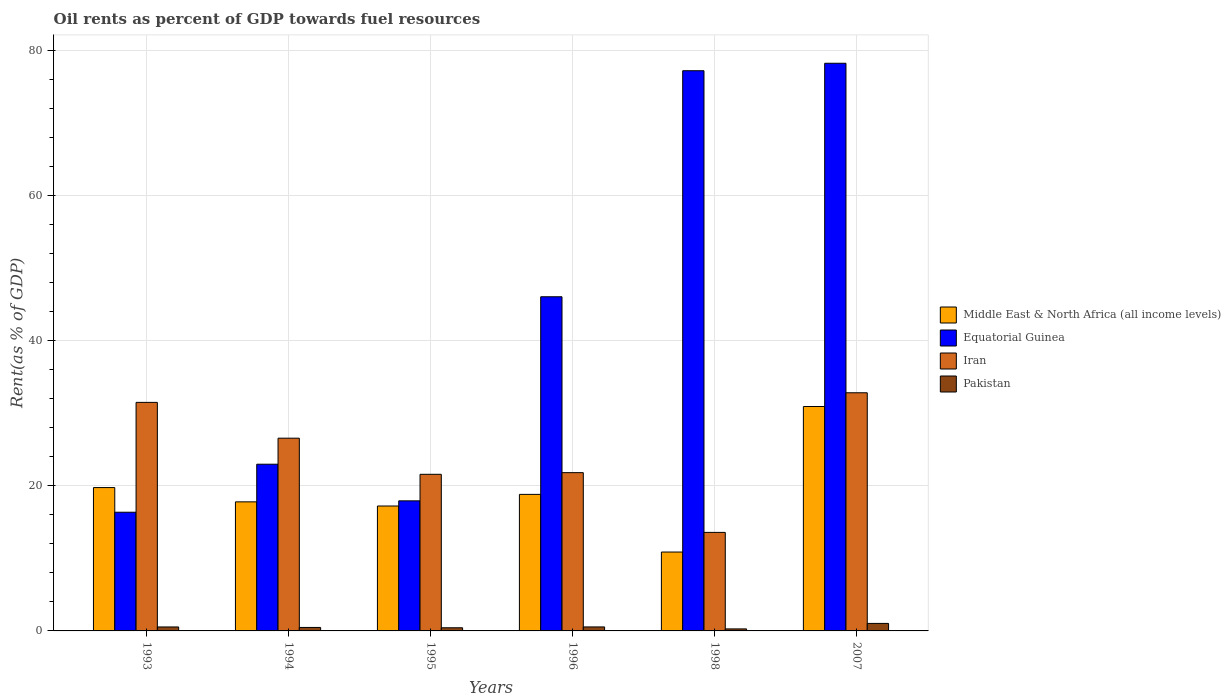How many bars are there on the 5th tick from the right?
Make the answer very short. 4. What is the label of the 3rd group of bars from the left?
Keep it short and to the point. 1995. In how many cases, is the number of bars for a given year not equal to the number of legend labels?
Keep it short and to the point. 0. What is the oil rent in Middle East & North Africa (all income levels) in 2007?
Give a very brief answer. 30.94. Across all years, what is the maximum oil rent in Iran?
Your response must be concise. 32.83. Across all years, what is the minimum oil rent in Pakistan?
Offer a terse response. 0.28. What is the total oil rent in Middle East & North Africa (all income levels) in the graph?
Provide a succinct answer. 115.41. What is the difference between the oil rent in Equatorial Guinea in 1996 and that in 1998?
Give a very brief answer. -31.16. What is the difference between the oil rent in Iran in 1994 and the oil rent in Pakistan in 1995?
Provide a succinct answer. 26.14. What is the average oil rent in Pakistan per year?
Your answer should be very brief. 0.55. In the year 1994, what is the difference between the oil rent in Middle East & North Africa (all income levels) and oil rent in Equatorial Guinea?
Make the answer very short. -5.19. What is the ratio of the oil rent in Equatorial Guinea in 1995 to that in 1996?
Offer a terse response. 0.39. Is the oil rent in Equatorial Guinea in 1996 less than that in 2007?
Ensure brevity in your answer.  Yes. What is the difference between the highest and the second highest oil rent in Iran?
Make the answer very short. 1.32. What is the difference between the highest and the lowest oil rent in Equatorial Guinea?
Keep it short and to the point. 61.89. In how many years, is the oil rent in Pakistan greater than the average oil rent in Pakistan taken over all years?
Your answer should be compact. 1. Is the sum of the oil rent in Equatorial Guinea in 1995 and 2007 greater than the maximum oil rent in Pakistan across all years?
Offer a terse response. Yes. Is it the case that in every year, the sum of the oil rent in Iran and oil rent in Middle East & North Africa (all income levels) is greater than the sum of oil rent in Pakistan and oil rent in Equatorial Guinea?
Your answer should be compact. No. What does the 3rd bar from the left in 1998 represents?
Provide a short and direct response. Iran. What does the 3rd bar from the right in 1995 represents?
Provide a short and direct response. Equatorial Guinea. Is it the case that in every year, the sum of the oil rent in Iran and oil rent in Pakistan is greater than the oil rent in Equatorial Guinea?
Make the answer very short. No. How many bars are there?
Give a very brief answer. 24. Are all the bars in the graph horizontal?
Your response must be concise. No. How many years are there in the graph?
Offer a terse response. 6. What is the difference between two consecutive major ticks on the Y-axis?
Your answer should be very brief. 20. Does the graph contain grids?
Your answer should be compact. Yes. How many legend labels are there?
Make the answer very short. 4. What is the title of the graph?
Your response must be concise. Oil rents as percent of GDP towards fuel resources. Does "Upper middle income" appear as one of the legend labels in the graph?
Offer a terse response. No. What is the label or title of the X-axis?
Your answer should be very brief. Years. What is the label or title of the Y-axis?
Give a very brief answer. Rent(as % of GDP). What is the Rent(as % of GDP) in Middle East & North Africa (all income levels) in 1993?
Your response must be concise. 19.76. What is the Rent(as % of GDP) of Equatorial Guinea in 1993?
Your response must be concise. 16.36. What is the Rent(as % of GDP) in Iran in 1993?
Offer a very short reply. 31.51. What is the Rent(as % of GDP) in Pakistan in 1993?
Provide a succinct answer. 0.55. What is the Rent(as % of GDP) of Middle East & North Africa (all income levels) in 1994?
Your answer should be very brief. 17.79. What is the Rent(as % of GDP) in Equatorial Guinea in 1994?
Your answer should be compact. 22.98. What is the Rent(as % of GDP) of Iran in 1994?
Provide a succinct answer. 26.57. What is the Rent(as % of GDP) of Pakistan in 1994?
Your answer should be very brief. 0.48. What is the Rent(as % of GDP) of Middle East & North Africa (all income levels) in 1995?
Give a very brief answer. 17.22. What is the Rent(as % of GDP) of Equatorial Guinea in 1995?
Provide a short and direct response. 17.93. What is the Rent(as % of GDP) of Iran in 1995?
Keep it short and to the point. 21.59. What is the Rent(as % of GDP) of Pakistan in 1995?
Offer a terse response. 0.43. What is the Rent(as % of GDP) of Middle East & North Africa (all income levels) in 1996?
Your answer should be very brief. 18.82. What is the Rent(as % of GDP) in Equatorial Guinea in 1996?
Your answer should be compact. 46.07. What is the Rent(as % of GDP) in Iran in 1996?
Your answer should be compact. 21.82. What is the Rent(as % of GDP) in Pakistan in 1996?
Keep it short and to the point. 0.55. What is the Rent(as % of GDP) in Middle East & North Africa (all income levels) in 1998?
Make the answer very short. 10.87. What is the Rent(as % of GDP) of Equatorial Guinea in 1998?
Keep it short and to the point. 77.23. What is the Rent(as % of GDP) of Iran in 1998?
Make the answer very short. 13.58. What is the Rent(as % of GDP) in Pakistan in 1998?
Give a very brief answer. 0.28. What is the Rent(as % of GDP) in Middle East & North Africa (all income levels) in 2007?
Your answer should be compact. 30.94. What is the Rent(as % of GDP) of Equatorial Guinea in 2007?
Keep it short and to the point. 78.25. What is the Rent(as % of GDP) of Iran in 2007?
Your answer should be very brief. 32.83. What is the Rent(as % of GDP) of Pakistan in 2007?
Make the answer very short. 1.03. Across all years, what is the maximum Rent(as % of GDP) in Middle East & North Africa (all income levels)?
Provide a succinct answer. 30.94. Across all years, what is the maximum Rent(as % of GDP) in Equatorial Guinea?
Offer a terse response. 78.25. Across all years, what is the maximum Rent(as % of GDP) in Iran?
Your answer should be compact. 32.83. Across all years, what is the maximum Rent(as % of GDP) in Pakistan?
Ensure brevity in your answer.  1.03. Across all years, what is the minimum Rent(as % of GDP) of Middle East & North Africa (all income levels)?
Offer a very short reply. 10.87. Across all years, what is the minimum Rent(as % of GDP) in Equatorial Guinea?
Offer a terse response. 16.36. Across all years, what is the minimum Rent(as % of GDP) in Iran?
Provide a succinct answer. 13.58. Across all years, what is the minimum Rent(as % of GDP) in Pakistan?
Ensure brevity in your answer.  0.28. What is the total Rent(as % of GDP) in Middle East & North Africa (all income levels) in the graph?
Your answer should be very brief. 115.41. What is the total Rent(as % of GDP) in Equatorial Guinea in the graph?
Your response must be concise. 258.82. What is the total Rent(as % of GDP) in Iran in the graph?
Your response must be concise. 147.89. What is the total Rent(as % of GDP) in Pakistan in the graph?
Ensure brevity in your answer.  3.32. What is the difference between the Rent(as % of GDP) in Middle East & North Africa (all income levels) in 1993 and that in 1994?
Offer a terse response. 1.97. What is the difference between the Rent(as % of GDP) of Equatorial Guinea in 1993 and that in 1994?
Offer a very short reply. -6.62. What is the difference between the Rent(as % of GDP) of Iran in 1993 and that in 1994?
Your response must be concise. 4.94. What is the difference between the Rent(as % of GDP) of Pakistan in 1993 and that in 1994?
Provide a short and direct response. 0.07. What is the difference between the Rent(as % of GDP) in Middle East & North Africa (all income levels) in 1993 and that in 1995?
Your answer should be very brief. 2.54. What is the difference between the Rent(as % of GDP) of Equatorial Guinea in 1993 and that in 1995?
Offer a terse response. -1.57. What is the difference between the Rent(as % of GDP) in Iran in 1993 and that in 1995?
Give a very brief answer. 9.92. What is the difference between the Rent(as % of GDP) in Pakistan in 1993 and that in 1995?
Ensure brevity in your answer.  0.11. What is the difference between the Rent(as % of GDP) of Middle East & North Africa (all income levels) in 1993 and that in 1996?
Your answer should be compact. 0.94. What is the difference between the Rent(as % of GDP) in Equatorial Guinea in 1993 and that in 1996?
Offer a terse response. -29.7. What is the difference between the Rent(as % of GDP) in Iran in 1993 and that in 1996?
Offer a terse response. 9.69. What is the difference between the Rent(as % of GDP) of Pakistan in 1993 and that in 1996?
Your answer should be very brief. -0. What is the difference between the Rent(as % of GDP) of Middle East & North Africa (all income levels) in 1993 and that in 1998?
Offer a terse response. 8.89. What is the difference between the Rent(as % of GDP) of Equatorial Guinea in 1993 and that in 1998?
Give a very brief answer. -60.86. What is the difference between the Rent(as % of GDP) of Iran in 1993 and that in 1998?
Offer a very short reply. 17.92. What is the difference between the Rent(as % of GDP) in Pakistan in 1993 and that in 1998?
Ensure brevity in your answer.  0.27. What is the difference between the Rent(as % of GDP) of Middle East & North Africa (all income levels) in 1993 and that in 2007?
Provide a short and direct response. -11.17. What is the difference between the Rent(as % of GDP) of Equatorial Guinea in 1993 and that in 2007?
Provide a succinct answer. -61.89. What is the difference between the Rent(as % of GDP) in Iran in 1993 and that in 2007?
Your response must be concise. -1.32. What is the difference between the Rent(as % of GDP) of Pakistan in 1993 and that in 2007?
Your answer should be compact. -0.49. What is the difference between the Rent(as % of GDP) in Middle East & North Africa (all income levels) in 1994 and that in 1995?
Offer a very short reply. 0.57. What is the difference between the Rent(as % of GDP) in Equatorial Guinea in 1994 and that in 1995?
Offer a very short reply. 5.05. What is the difference between the Rent(as % of GDP) of Iran in 1994 and that in 1995?
Your answer should be compact. 4.98. What is the difference between the Rent(as % of GDP) in Pakistan in 1994 and that in 1995?
Provide a succinct answer. 0.04. What is the difference between the Rent(as % of GDP) in Middle East & North Africa (all income levels) in 1994 and that in 1996?
Provide a short and direct response. -1.03. What is the difference between the Rent(as % of GDP) of Equatorial Guinea in 1994 and that in 1996?
Ensure brevity in your answer.  -23.08. What is the difference between the Rent(as % of GDP) in Iran in 1994 and that in 1996?
Offer a very short reply. 4.75. What is the difference between the Rent(as % of GDP) of Pakistan in 1994 and that in 1996?
Provide a succinct answer. -0.07. What is the difference between the Rent(as % of GDP) of Middle East & North Africa (all income levels) in 1994 and that in 1998?
Offer a terse response. 6.92. What is the difference between the Rent(as % of GDP) of Equatorial Guinea in 1994 and that in 1998?
Offer a terse response. -54.25. What is the difference between the Rent(as % of GDP) in Iran in 1994 and that in 1998?
Offer a terse response. 12.99. What is the difference between the Rent(as % of GDP) of Pakistan in 1994 and that in 1998?
Keep it short and to the point. 0.2. What is the difference between the Rent(as % of GDP) in Middle East & North Africa (all income levels) in 1994 and that in 2007?
Provide a succinct answer. -13.14. What is the difference between the Rent(as % of GDP) in Equatorial Guinea in 1994 and that in 2007?
Provide a succinct answer. -55.27. What is the difference between the Rent(as % of GDP) in Iran in 1994 and that in 2007?
Your response must be concise. -6.26. What is the difference between the Rent(as % of GDP) in Pakistan in 1994 and that in 2007?
Ensure brevity in your answer.  -0.56. What is the difference between the Rent(as % of GDP) in Middle East & North Africa (all income levels) in 1995 and that in 1996?
Provide a succinct answer. -1.6. What is the difference between the Rent(as % of GDP) of Equatorial Guinea in 1995 and that in 1996?
Keep it short and to the point. -28.14. What is the difference between the Rent(as % of GDP) of Iran in 1995 and that in 1996?
Provide a succinct answer. -0.23. What is the difference between the Rent(as % of GDP) of Pakistan in 1995 and that in 1996?
Ensure brevity in your answer.  -0.12. What is the difference between the Rent(as % of GDP) of Middle East & North Africa (all income levels) in 1995 and that in 1998?
Offer a very short reply. 6.35. What is the difference between the Rent(as % of GDP) in Equatorial Guinea in 1995 and that in 1998?
Your answer should be compact. -59.3. What is the difference between the Rent(as % of GDP) in Iran in 1995 and that in 1998?
Provide a succinct answer. 8.01. What is the difference between the Rent(as % of GDP) of Pakistan in 1995 and that in 1998?
Give a very brief answer. 0.16. What is the difference between the Rent(as % of GDP) of Middle East & North Africa (all income levels) in 1995 and that in 2007?
Your answer should be very brief. -13.72. What is the difference between the Rent(as % of GDP) of Equatorial Guinea in 1995 and that in 2007?
Provide a short and direct response. -60.32. What is the difference between the Rent(as % of GDP) of Iran in 1995 and that in 2007?
Your answer should be very brief. -11.24. What is the difference between the Rent(as % of GDP) in Pakistan in 1995 and that in 2007?
Offer a terse response. -0.6. What is the difference between the Rent(as % of GDP) in Middle East & North Africa (all income levels) in 1996 and that in 1998?
Make the answer very short. 7.95. What is the difference between the Rent(as % of GDP) of Equatorial Guinea in 1996 and that in 1998?
Provide a succinct answer. -31.16. What is the difference between the Rent(as % of GDP) in Iran in 1996 and that in 1998?
Offer a very short reply. 8.24. What is the difference between the Rent(as % of GDP) in Pakistan in 1996 and that in 1998?
Your answer should be compact. 0.27. What is the difference between the Rent(as % of GDP) of Middle East & North Africa (all income levels) in 1996 and that in 2007?
Make the answer very short. -12.12. What is the difference between the Rent(as % of GDP) of Equatorial Guinea in 1996 and that in 2007?
Ensure brevity in your answer.  -32.19. What is the difference between the Rent(as % of GDP) in Iran in 1996 and that in 2007?
Ensure brevity in your answer.  -11.01. What is the difference between the Rent(as % of GDP) of Pakistan in 1996 and that in 2007?
Provide a short and direct response. -0.48. What is the difference between the Rent(as % of GDP) of Middle East & North Africa (all income levels) in 1998 and that in 2007?
Provide a succinct answer. -20.06. What is the difference between the Rent(as % of GDP) in Equatorial Guinea in 1998 and that in 2007?
Give a very brief answer. -1.03. What is the difference between the Rent(as % of GDP) in Iran in 1998 and that in 2007?
Provide a succinct answer. -19.25. What is the difference between the Rent(as % of GDP) of Pakistan in 1998 and that in 2007?
Offer a very short reply. -0.76. What is the difference between the Rent(as % of GDP) of Middle East & North Africa (all income levels) in 1993 and the Rent(as % of GDP) of Equatorial Guinea in 1994?
Ensure brevity in your answer.  -3.22. What is the difference between the Rent(as % of GDP) in Middle East & North Africa (all income levels) in 1993 and the Rent(as % of GDP) in Iran in 1994?
Provide a succinct answer. -6.81. What is the difference between the Rent(as % of GDP) in Middle East & North Africa (all income levels) in 1993 and the Rent(as % of GDP) in Pakistan in 1994?
Give a very brief answer. 19.28. What is the difference between the Rent(as % of GDP) of Equatorial Guinea in 1993 and the Rent(as % of GDP) of Iran in 1994?
Your answer should be very brief. -10.21. What is the difference between the Rent(as % of GDP) of Equatorial Guinea in 1993 and the Rent(as % of GDP) of Pakistan in 1994?
Your answer should be compact. 15.88. What is the difference between the Rent(as % of GDP) of Iran in 1993 and the Rent(as % of GDP) of Pakistan in 1994?
Offer a very short reply. 31.03. What is the difference between the Rent(as % of GDP) of Middle East & North Africa (all income levels) in 1993 and the Rent(as % of GDP) of Equatorial Guinea in 1995?
Offer a very short reply. 1.83. What is the difference between the Rent(as % of GDP) of Middle East & North Africa (all income levels) in 1993 and the Rent(as % of GDP) of Iran in 1995?
Keep it short and to the point. -1.83. What is the difference between the Rent(as % of GDP) in Middle East & North Africa (all income levels) in 1993 and the Rent(as % of GDP) in Pakistan in 1995?
Provide a succinct answer. 19.33. What is the difference between the Rent(as % of GDP) of Equatorial Guinea in 1993 and the Rent(as % of GDP) of Iran in 1995?
Ensure brevity in your answer.  -5.23. What is the difference between the Rent(as % of GDP) in Equatorial Guinea in 1993 and the Rent(as % of GDP) in Pakistan in 1995?
Ensure brevity in your answer.  15.93. What is the difference between the Rent(as % of GDP) in Iran in 1993 and the Rent(as % of GDP) in Pakistan in 1995?
Your answer should be very brief. 31.07. What is the difference between the Rent(as % of GDP) in Middle East & North Africa (all income levels) in 1993 and the Rent(as % of GDP) in Equatorial Guinea in 1996?
Give a very brief answer. -26.3. What is the difference between the Rent(as % of GDP) in Middle East & North Africa (all income levels) in 1993 and the Rent(as % of GDP) in Iran in 1996?
Offer a very short reply. -2.06. What is the difference between the Rent(as % of GDP) in Middle East & North Africa (all income levels) in 1993 and the Rent(as % of GDP) in Pakistan in 1996?
Offer a terse response. 19.21. What is the difference between the Rent(as % of GDP) of Equatorial Guinea in 1993 and the Rent(as % of GDP) of Iran in 1996?
Your response must be concise. -5.46. What is the difference between the Rent(as % of GDP) in Equatorial Guinea in 1993 and the Rent(as % of GDP) in Pakistan in 1996?
Your response must be concise. 15.81. What is the difference between the Rent(as % of GDP) in Iran in 1993 and the Rent(as % of GDP) in Pakistan in 1996?
Provide a short and direct response. 30.95. What is the difference between the Rent(as % of GDP) in Middle East & North Africa (all income levels) in 1993 and the Rent(as % of GDP) in Equatorial Guinea in 1998?
Your response must be concise. -57.46. What is the difference between the Rent(as % of GDP) in Middle East & North Africa (all income levels) in 1993 and the Rent(as % of GDP) in Iran in 1998?
Your response must be concise. 6.18. What is the difference between the Rent(as % of GDP) in Middle East & North Africa (all income levels) in 1993 and the Rent(as % of GDP) in Pakistan in 1998?
Your answer should be compact. 19.48. What is the difference between the Rent(as % of GDP) in Equatorial Guinea in 1993 and the Rent(as % of GDP) in Iran in 1998?
Ensure brevity in your answer.  2.78. What is the difference between the Rent(as % of GDP) in Equatorial Guinea in 1993 and the Rent(as % of GDP) in Pakistan in 1998?
Your response must be concise. 16.08. What is the difference between the Rent(as % of GDP) of Iran in 1993 and the Rent(as % of GDP) of Pakistan in 1998?
Give a very brief answer. 31.23. What is the difference between the Rent(as % of GDP) of Middle East & North Africa (all income levels) in 1993 and the Rent(as % of GDP) of Equatorial Guinea in 2007?
Your response must be concise. -58.49. What is the difference between the Rent(as % of GDP) in Middle East & North Africa (all income levels) in 1993 and the Rent(as % of GDP) in Iran in 2007?
Provide a succinct answer. -13.07. What is the difference between the Rent(as % of GDP) of Middle East & North Africa (all income levels) in 1993 and the Rent(as % of GDP) of Pakistan in 2007?
Provide a short and direct response. 18.73. What is the difference between the Rent(as % of GDP) of Equatorial Guinea in 1993 and the Rent(as % of GDP) of Iran in 2007?
Ensure brevity in your answer.  -16.47. What is the difference between the Rent(as % of GDP) in Equatorial Guinea in 1993 and the Rent(as % of GDP) in Pakistan in 2007?
Your answer should be compact. 15.33. What is the difference between the Rent(as % of GDP) of Iran in 1993 and the Rent(as % of GDP) of Pakistan in 2007?
Make the answer very short. 30.47. What is the difference between the Rent(as % of GDP) of Middle East & North Africa (all income levels) in 1994 and the Rent(as % of GDP) of Equatorial Guinea in 1995?
Offer a terse response. -0.14. What is the difference between the Rent(as % of GDP) in Middle East & North Africa (all income levels) in 1994 and the Rent(as % of GDP) in Iran in 1995?
Provide a short and direct response. -3.8. What is the difference between the Rent(as % of GDP) of Middle East & North Africa (all income levels) in 1994 and the Rent(as % of GDP) of Pakistan in 1995?
Your response must be concise. 17.36. What is the difference between the Rent(as % of GDP) in Equatorial Guinea in 1994 and the Rent(as % of GDP) in Iran in 1995?
Offer a very short reply. 1.39. What is the difference between the Rent(as % of GDP) in Equatorial Guinea in 1994 and the Rent(as % of GDP) in Pakistan in 1995?
Ensure brevity in your answer.  22.55. What is the difference between the Rent(as % of GDP) in Iran in 1994 and the Rent(as % of GDP) in Pakistan in 1995?
Give a very brief answer. 26.14. What is the difference between the Rent(as % of GDP) of Middle East & North Africa (all income levels) in 1994 and the Rent(as % of GDP) of Equatorial Guinea in 1996?
Offer a very short reply. -28.27. What is the difference between the Rent(as % of GDP) of Middle East & North Africa (all income levels) in 1994 and the Rent(as % of GDP) of Iran in 1996?
Your answer should be very brief. -4.03. What is the difference between the Rent(as % of GDP) of Middle East & North Africa (all income levels) in 1994 and the Rent(as % of GDP) of Pakistan in 1996?
Make the answer very short. 17.24. What is the difference between the Rent(as % of GDP) in Equatorial Guinea in 1994 and the Rent(as % of GDP) in Iran in 1996?
Ensure brevity in your answer.  1.16. What is the difference between the Rent(as % of GDP) of Equatorial Guinea in 1994 and the Rent(as % of GDP) of Pakistan in 1996?
Give a very brief answer. 22.43. What is the difference between the Rent(as % of GDP) of Iran in 1994 and the Rent(as % of GDP) of Pakistan in 1996?
Ensure brevity in your answer.  26.02. What is the difference between the Rent(as % of GDP) in Middle East & North Africa (all income levels) in 1994 and the Rent(as % of GDP) in Equatorial Guinea in 1998?
Make the answer very short. -59.43. What is the difference between the Rent(as % of GDP) in Middle East & North Africa (all income levels) in 1994 and the Rent(as % of GDP) in Iran in 1998?
Your answer should be compact. 4.21. What is the difference between the Rent(as % of GDP) of Middle East & North Africa (all income levels) in 1994 and the Rent(as % of GDP) of Pakistan in 1998?
Keep it short and to the point. 17.51. What is the difference between the Rent(as % of GDP) of Equatorial Guinea in 1994 and the Rent(as % of GDP) of Iran in 1998?
Ensure brevity in your answer.  9.4. What is the difference between the Rent(as % of GDP) of Equatorial Guinea in 1994 and the Rent(as % of GDP) of Pakistan in 1998?
Give a very brief answer. 22.7. What is the difference between the Rent(as % of GDP) in Iran in 1994 and the Rent(as % of GDP) in Pakistan in 1998?
Provide a short and direct response. 26.29. What is the difference between the Rent(as % of GDP) of Middle East & North Africa (all income levels) in 1994 and the Rent(as % of GDP) of Equatorial Guinea in 2007?
Make the answer very short. -60.46. What is the difference between the Rent(as % of GDP) in Middle East & North Africa (all income levels) in 1994 and the Rent(as % of GDP) in Iran in 2007?
Provide a short and direct response. -15.04. What is the difference between the Rent(as % of GDP) in Middle East & North Africa (all income levels) in 1994 and the Rent(as % of GDP) in Pakistan in 2007?
Your answer should be very brief. 16.76. What is the difference between the Rent(as % of GDP) of Equatorial Guinea in 1994 and the Rent(as % of GDP) of Iran in 2007?
Keep it short and to the point. -9.85. What is the difference between the Rent(as % of GDP) in Equatorial Guinea in 1994 and the Rent(as % of GDP) in Pakistan in 2007?
Make the answer very short. 21.95. What is the difference between the Rent(as % of GDP) in Iran in 1994 and the Rent(as % of GDP) in Pakistan in 2007?
Offer a terse response. 25.54. What is the difference between the Rent(as % of GDP) of Middle East & North Africa (all income levels) in 1995 and the Rent(as % of GDP) of Equatorial Guinea in 1996?
Keep it short and to the point. -28.85. What is the difference between the Rent(as % of GDP) of Middle East & North Africa (all income levels) in 1995 and the Rent(as % of GDP) of Iran in 1996?
Your answer should be compact. -4.6. What is the difference between the Rent(as % of GDP) in Middle East & North Africa (all income levels) in 1995 and the Rent(as % of GDP) in Pakistan in 1996?
Provide a short and direct response. 16.67. What is the difference between the Rent(as % of GDP) in Equatorial Guinea in 1995 and the Rent(as % of GDP) in Iran in 1996?
Give a very brief answer. -3.89. What is the difference between the Rent(as % of GDP) of Equatorial Guinea in 1995 and the Rent(as % of GDP) of Pakistan in 1996?
Provide a succinct answer. 17.38. What is the difference between the Rent(as % of GDP) of Iran in 1995 and the Rent(as % of GDP) of Pakistan in 1996?
Ensure brevity in your answer.  21.04. What is the difference between the Rent(as % of GDP) in Middle East & North Africa (all income levels) in 1995 and the Rent(as % of GDP) in Equatorial Guinea in 1998?
Give a very brief answer. -60.01. What is the difference between the Rent(as % of GDP) in Middle East & North Africa (all income levels) in 1995 and the Rent(as % of GDP) in Iran in 1998?
Keep it short and to the point. 3.64. What is the difference between the Rent(as % of GDP) of Middle East & North Africa (all income levels) in 1995 and the Rent(as % of GDP) of Pakistan in 1998?
Provide a short and direct response. 16.94. What is the difference between the Rent(as % of GDP) in Equatorial Guinea in 1995 and the Rent(as % of GDP) in Iran in 1998?
Keep it short and to the point. 4.35. What is the difference between the Rent(as % of GDP) in Equatorial Guinea in 1995 and the Rent(as % of GDP) in Pakistan in 1998?
Provide a succinct answer. 17.65. What is the difference between the Rent(as % of GDP) in Iran in 1995 and the Rent(as % of GDP) in Pakistan in 1998?
Offer a very short reply. 21.31. What is the difference between the Rent(as % of GDP) in Middle East & North Africa (all income levels) in 1995 and the Rent(as % of GDP) in Equatorial Guinea in 2007?
Provide a succinct answer. -61.03. What is the difference between the Rent(as % of GDP) of Middle East & North Africa (all income levels) in 1995 and the Rent(as % of GDP) of Iran in 2007?
Your answer should be very brief. -15.61. What is the difference between the Rent(as % of GDP) of Middle East & North Africa (all income levels) in 1995 and the Rent(as % of GDP) of Pakistan in 2007?
Give a very brief answer. 16.19. What is the difference between the Rent(as % of GDP) in Equatorial Guinea in 1995 and the Rent(as % of GDP) in Iran in 2007?
Keep it short and to the point. -14.9. What is the difference between the Rent(as % of GDP) in Equatorial Guinea in 1995 and the Rent(as % of GDP) in Pakistan in 2007?
Offer a terse response. 16.9. What is the difference between the Rent(as % of GDP) in Iran in 1995 and the Rent(as % of GDP) in Pakistan in 2007?
Offer a very short reply. 20.55. What is the difference between the Rent(as % of GDP) in Middle East & North Africa (all income levels) in 1996 and the Rent(as % of GDP) in Equatorial Guinea in 1998?
Give a very brief answer. -58.4. What is the difference between the Rent(as % of GDP) in Middle East & North Africa (all income levels) in 1996 and the Rent(as % of GDP) in Iran in 1998?
Offer a terse response. 5.24. What is the difference between the Rent(as % of GDP) of Middle East & North Africa (all income levels) in 1996 and the Rent(as % of GDP) of Pakistan in 1998?
Keep it short and to the point. 18.54. What is the difference between the Rent(as % of GDP) in Equatorial Guinea in 1996 and the Rent(as % of GDP) in Iran in 1998?
Ensure brevity in your answer.  32.48. What is the difference between the Rent(as % of GDP) of Equatorial Guinea in 1996 and the Rent(as % of GDP) of Pakistan in 1998?
Your response must be concise. 45.79. What is the difference between the Rent(as % of GDP) of Iran in 1996 and the Rent(as % of GDP) of Pakistan in 1998?
Ensure brevity in your answer.  21.54. What is the difference between the Rent(as % of GDP) in Middle East & North Africa (all income levels) in 1996 and the Rent(as % of GDP) in Equatorial Guinea in 2007?
Your answer should be compact. -59.43. What is the difference between the Rent(as % of GDP) of Middle East & North Africa (all income levels) in 1996 and the Rent(as % of GDP) of Iran in 2007?
Offer a very short reply. -14.01. What is the difference between the Rent(as % of GDP) in Middle East & North Africa (all income levels) in 1996 and the Rent(as % of GDP) in Pakistan in 2007?
Your answer should be compact. 17.79. What is the difference between the Rent(as % of GDP) of Equatorial Guinea in 1996 and the Rent(as % of GDP) of Iran in 2007?
Your answer should be very brief. 13.24. What is the difference between the Rent(as % of GDP) of Equatorial Guinea in 1996 and the Rent(as % of GDP) of Pakistan in 2007?
Keep it short and to the point. 45.03. What is the difference between the Rent(as % of GDP) in Iran in 1996 and the Rent(as % of GDP) in Pakistan in 2007?
Ensure brevity in your answer.  20.78. What is the difference between the Rent(as % of GDP) of Middle East & North Africa (all income levels) in 1998 and the Rent(as % of GDP) of Equatorial Guinea in 2007?
Provide a succinct answer. -67.38. What is the difference between the Rent(as % of GDP) of Middle East & North Africa (all income levels) in 1998 and the Rent(as % of GDP) of Iran in 2007?
Provide a succinct answer. -21.96. What is the difference between the Rent(as % of GDP) of Middle East & North Africa (all income levels) in 1998 and the Rent(as % of GDP) of Pakistan in 2007?
Give a very brief answer. 9.84. What is the difference between the Rent(as % of GDP) of Equatorial Guinea in 1998 and the Rent(as % of GDP) of Iran in 2007?
Give a very brief answer. 44.4. What is the difference between the Rent(as % of GDP) of Equatorial Guinea in 1998 and the Rent(as % of GDP) of Pakistan in 2007?
Your answer should be very brief. 76.19. What is the difference between the Rent(as % of GDP) in Iran in 1998 and the Rent(as % of GDP) in Pakistan in 2007?
Keep it short and to the point. 12.55. What is the average Rent(as % of GDP) of Middle East & North Africa (all income levels) per year?
Give a very brief answer. 19.23. What is the average Rent(as % of GDP) of Equatorial Guinea per year?
Keep it short and to the point. 43.14. What is the average Rent(as % of GDP) in Iran per year?
Ensure brevity in your answer.  24.65. What is the average Rent(as % of GDP) in Pakistan per year?
Ensure brevity in your answer.  0.55. In the year 1993, what is the difference between the Rent(as % of GDP) of Middle East & North Africa (all income levels) and Rent(as % of GDP) of Equatorial Guinea?
Provide a succinct answer. 3.4. In the year 1993, what is the difference between the Rent(as % of GDP) in Middle East & North Africa (all income levels) and Rent(as % of GDP) in Iran?
Your answer should be compact. -11.74. In the year 1993, what is the difference between the Rent(as % of GDP) in Middle East & North Africa (all income levels) and Rent(as % of GDP) in Pakistan?
Keep it short and to the point. 19.22. In the year 1993, what is the difference between the Rent(as % of GDP) of Equatorial Guinea and Rent(as % of GDP) of Iran?
Make the answer very short. -15.14. In the year 1993, what is the difference between the Rent(as % of GDP) in Equatorial Guinea and Rent(as % of GDP) in Pakistan?
Your answer should be compact. 15.82. In the year 1993, what is the difference between the Rent(as % of GDP) of Iran and Rent(as % of GDP) of Pakistan?
Keep it short and to the point. 30.96. In the year 1994, what is the difference between the Rent(as % of GDP) of Middle East & North Africa (all income levels) and Rent(as % of GDP) of Equatorial Guinea?
Your response must be concise. -5.19. In the year 1994, what is the difference between the Rent(as % of GDP) in Middle East & North Africa (all income levels) and Rent(as % of GDP) in Iran?
Keep it short and to the point. -8.78. In the year 1994, what is the difference between the Rent(as % of GDP) of Middle East & North Africa (all income levels) and Rent(as % of GDP) of Pakistan?
Provide a short and direct response. 17.31. In the year 1994, what is the difference between the Rent(as % of GDP) in Equatorial Guinea and Rent(as % of GDP) in Iran?
Keep it short and to the point. -3.59. In the year 1994, what is the difference between the Rent(as % of GDP) of Equatorial Guinea and Rent(as % of GDP) of Pakistan?
Your answer should be compact. 22.5. In the year 1994, what is the difference between the Rent(as % of GDP) of Iran and Rent(as % of GDP) of Pakistan?
Your response must be concise. 26.09. In the year 1995, what is the difference between the Rent(as % of GDP) of Middle East & North Africa (all income levels) and Rent(as % of GDP) of Equatorial Guinea?
Your answer should be very brief. -0.71. In the year 1995, what is the difference between the Rent(as % of GDP) in Middle East & North Africa (all income levels) and Rent(as % of GDP) in Iran?
Offer a very short reply. -4.37. In the year 1995, what is the difference between the Rent(as % of GDP) of Middle East & North Africa (all income levels) and Rent(as % of GDP) of Pakistan?
Provide a succinct answer. 16.79. In the year 1995, what is the difference between the Rent(as % of GDP) of Equatorial Guinea and Rent(as % of GDP) of Iran?
Your response must be concise. -3.66. In the year 1995, what is the difference between the Rent(as % of GDP) of Equatorial Guinea and Rent(as % of GDP) of Pakistan?
Make the answer very short. 17.5. In the year 1995, what is the difference between the Rent(as % of GDP) in Iran and Rent(as % of GDP) in Pakistan?
Provide a succinct answer. 21.16. In the year 1996, what is the difference between the Rent(as % of GDP) in Middle East & North Africa (all income levels) and Rent(as % of GDP) in Equatorial Guinea?
Offer a terse response. -27.24. In the year 1996, what is the difference between the Rent(as % of GDP) in Middle East & North Africa (all income levels) and Rent(as % of GDP) in Iran?
Provide a succinct answer. -3. In the year 1996, what is the difference between the Rent(as % of GDP) of Middle East & North Africa (all income levels) and Rent(as % of GDP) of Pakistan?
Ensure brevity in your answer.  18.27. In the year 1996, what is the difference between the Rent(as % of GDP) in Equatorial Guinea and Rent(as % of GDP) in Iran?
Your response must be concise. 24.25. In the year 1996, what is the difference between the Rent(as % of GDP) of Equatorial Guinea and Rent(as % of GDP) of Pakistan?
Your answer should be very brief. 45.51. In the year 1996, what is the difference between the Rent(as % of GDP) in Iran and Rent(as % of GDP) in Pakistan?
Give a very brief answer. 21.27. In the year 1998, what is the difference between the Rent(as % of GDP) of Middle East & North Africa (all income levels) and Rent(as % of GDP) of Equatorial Guinea?
Offer a very short reply. -66.35. In the year 1998, what is the difference between the Rent(as % of GDP) of Middle East & North Africa (all income levels) and Rent(as % of GDP) of Iran?
Provide a succinct answer. -2.71. In the year 1998, what is the difference between the Rent(as % of GDP) in Middle East & North Africa (all income levels) and Rent(as % of GDP) in Pakistan?
Ensure brevity in your answer.  10.59. In the year 1998, what is the difference between the Rent(as % of GDP) of Equatorial Guinea and Rent(as % of GDP) of Iran?
Your answer should be compact. 63.64. In the year 1998, what is the difference between the Rent(as % of GDP) in Equatorial Guinea and Rent(as % of GDP) in Pakistan?
Your answer should be compact. 76.95. In the year 1998, what is the difference between the Rent(as % of GDP) in Iran and Rent(as % of GDP) in Pakistan?
Give a very brief answer. 13.3. In the year 2007, what is the difference between the Rent(as % of GDP) of Middle East & North Africa (all income levels) and Rent(as % of GDP) of Equatorial Guinea?
Ensure brevity in your answer.  -47.32. In the year 2007, what is the difference between the Rent(as % of GDP) in Middle East & North Africa (all income levels) and Rent(as % of GDP) in Iran?
Make the answer very short. -1.89. In the year 2007, what is the difference between the Rent(as % of GDP) in Middle East & North Africa (all income levels) and Rent(as % of GDP) in Pakistan?
Make the answer very short. 29.9. In the year 2007, what is the difference between the Rent(as % of GDP) in Equatorial Guinea and Rent(as % of GDP) in Iran?
Offer a terse response. 45.43. In the year 2007, what is the difference between the Rent(as % of GDP) in Equatorial Guinea and Rent(as % of GDP) in Pakistan?
Your answer should be very brief. 77.22. In the year 2007, what is the difference between the Rent(as % of GDP) of Iran and Rent(as % of GDP) of Pakistan?
Make the answer very short. 31.79. What is the ratio of the Rent(as % of GDP) in Middle East & North Africa (all income levels) in 1993 to that in 1994?
Your response must be concise. 1.11. What is the ratio of the Rent(as % of GDP) in Equatorial Guinea in 1993 to that in 1994?
Offer a terse response. 0.71. What is the ratio of the Rent(as % of GDP) in Iran in 1993 to that in 1994?
Give a very brief answer. 1.19. What is the ratio of the Rent(as % of GDP) in Pakistan in 1993 to that in 1994?
Your response must be concise. 1.14. What is the ratio of the Rent(as % of GDP) in Middle East & North Africa (all income levels) in 1993 to that in 1995?
Make the answer very short. 1.15. What is the ratio of the Rent(as % of GDP) in Equatorial Guinea in 1993 to that in 1995?
Your response must be concise. 0.91. What is the ratio of the Rent(as % of GDP) in Iran in 1993 to that in 1995?
Offer a very short reply. 1.46. What is the ratio of the Rent(as % of GDP) of Pakistan in 1993 to that in 1995?
Provide a succinct answer. 1.26. What is the ratio of the Rent(as % of GDP) of Equatorial Guinea in 1993 to that in 1996?
Offer a terse response. 0.36. What is the ratio of the Rent(as % of GDP) of Iran in 1993 to that in 1996?
Your answer should be very brief. 1.44. What is the ratio of the Rent(as % of GDP) of Pakistan in 1993 to that in 1996?
Your response must be concise. 0.99. What is the ratio of the Rent(as % of GDP) in Middle East & North Africa (all income levels) in 1993 to that in 1998?
Offer a very short reply. 1.82. What is the ratio of the Rent(as % of GDP) in Equatorial Guinea in 1993 to that in 1998?
Ensure brevity in your answer.  0.21. What is the ratio of the Rent(as % of GDP) of Iran in 1993 to that in 1998?
Your response must be concise. 2.32. What is the ratio of the Rent(as % of GDP) of Pakistan in 1993 to that in 1998?
Keep it short and to the point. 1.96. What is the ratio of the Rent(as % of GDP) of Middle East & North Africa (all income levels) in 1993 to that in 2007?
Keep it short and to the point. 0.64. What is the ratio of the Rent(as % of GDP) in Equatorial Guinea in 1993 to that in 2007?
Offer a terse response. 0.21. What is the ratio of the Rent(as % of GDP) of Iran in 1993 to that in 2007?
Offer a terse response. 0.96. What is the ratio of the Rent(as % of GDP) in Pakistan in 1993 to that in 2007?
Offer a terse response. 0.53. What is the ratio of the Rent(as % of GDP) in Middle East & North Africa (all income levels) in 1994 to that in 1995?
Ensure brevity in your answer.  1.03. What is the ratio of the Rent(as % of GDP) in Equatorial Guinea in 1994 to that in 1995?
Give a very brief answer. 1.28. What is the ratio of the Rent(as % of GDP) of Iran in 1994 to that in 1995?
Keep it short and to the point. 1.23. What is the ratio of the Rent(as % of GDP) in Pakistan in 1994 to that in 1995?
Provide a short and direct response. 1.1. What is the ratio of the Rent(as % of GDP) of Middle East & North Africa (all income levels) in 1994 to that in 1996?
Give a very brief answer. 0.95. What is the ratio of the Rent(as % of GDP) in Equatorial Guinea in 1994 to that in 1996?
Your answer should be very brief. 0.5. What is the ratio of the Rent(as % of GDP) of Iran in 1994 to that in 1996?
Offer a terse response. 1.22. What is the ratio of the Rent(as % of GDP) of Pakistan in 1994 to that in 1996?
Provide a short and direct response. 0.87. What is the ratio of the Rent(as % of GDP) in Middle East & North Africa (all income levels) in 1994 to that in 1998?
Give a very brief answer. 1.64. What is the ratio of the Rent(as % of GDP) of Equatorial Guinea in 1994 to that in 1998?
Give a very brief answer. 0.3. What is the ratio of the Rent(as % of GDP) in Iran in 1994 to that in 1998?
Keep it short and to the point. 1.96. What is the ratio of the Rent(as % of GDP) of Pakistan in 1994 to that in 1998?
Offer a very short reply. 1.72. What is the ratio of the Rent(as % of GDP) of Middle East & North Africa (all income levels) in 1994 to that in 2007?
Your answer should be very brief. 0.58. What is the ratio of the Rent(as % of GDP) in Equatorial Guinea in 1994 to that in 2007?
Give a very brief answer. 0.29. What is the ratio of the Rent(as % of GDP) of Iran in 1994 to that in 2007?
Your response must be concise. 0.81. What is the ratio of the Rent(as % of GDP) of Pakistan in 1994 to that in 2007?
Offer a very short reply. 0.46. What is the ratio of the Rent(as % of GDP) in Middle East & North Africa (all income levels) in 1995 to that in 1996?
Keep it short and to the point. 0.91. What is the ratio of the Rent(as % of GDP) of Equatorial Guinea in 1995 to that in 1996?
Give a very brief answer. 0.39. What is the ratio of the Rent(as % of GDP) of Iran in 1995 to that in 1996?
Make the answer very short. 0.99. What is the ratio of the Rent(as % of GDP) of Pakistan in 1995 to that in 1996?
Keep it short and to the point. 0.79. What is the ratio of the Rent(as % of GDP) in Middle East & North Africa (all income levels) in 1995 to that in 1998?
Ensure brevity in your answer.  1.58. What is the ratio of the Rent(as % of GDP) of Equatorial Guinea in 1995 to that in 1998?
Make the answer very short. 0.23. What is the ratio of the Rent(as % of GDP) in Iran in 1995 to that in 1998?
Offer a terse response. 1.59. What is the ratio of the Rent(as % of GDP) of Pakistan in 1995 to that in 1998?
Offer a terse response. 1.56. What is the ratio of the Rent(as % of GDP) in Middle East & North Africa (all income levels) in 1995 to that in 2007?
Provide a short and direct response. 0.56. What is the ratio of the Rent(as % of GDP) in Equatorial Guinea in 1995 to that in 2007?
Offer a terse response. 0.23. What is the ratio of the Rent(as % of GDP) in Iran in 1995 to that in 2007?
Offer a terse response. 0.66. What is the ratio of the Rent(as % of GDP) of Pakistan in 1995 to that in 2007?
Offer a very short reply. 0.42. What is the ratio of the Rent(as % of GDP) in Middle East & North Africa (all income levels) in 1996 to that in 1998?
Give a very brief answer. 1.73. What is the ratio of the Rent(as % of GDP) of Equatorial Guinea in 1996 to that in 1998?
Keep it short and to the point. 0.6. What is the ratio of the Rent(as % of GDP) of Iran in 1996 to that in 1998?
Provide a short and direct response. 1.61. What is the ratio of the Rent(as % of GDP) of Pakistan in 1996 to that in 1998?
Your response must be concise. 1.98. What is the ratio of the Rent(as % of GDP) in Middle East & North Africa (all income levels) in 1996 to that in 2007?
Your answer should be compact. 0.61. What is the ratio of the Rent(as % of GDP) in Equatorial Guinea in 1996 to that in 2007?
Offer a terse response. 0.59. What is the ratio of the Rent(as % of GDP) in Iran in 1996 to that in 2007?
Provide a short and direct response. 0.66. What is the ratio of the Rent(as % of GDP) in Pakistan in 1996 to that in 2007?
Your answer should be very brief. 0.53. What is the ratio of the Rent(as % of GDP) in Middle East & North Africa (all income levels) in 1998 to that in 2007?
Make the answer very short. 0.35. What is the ratio of the Rent(as % of GDP) of Equatorial Guinea in 1998 to that in 2007?
Your response must be concise. 0.99. What is the ratio of the Rent(as % of GDP) in Iran in 1998 to that in 2007?
Provide a short and direct response. 0.41. What is the ratio of the Rent(as % of GDP) in Pakistan in 1998 to that in 2007?
Your answer should be compact. 0.27. What is the difference between the highest and the second highest Rent(as % of GDP) in Middle East & North Africa (all income levels)?
Make the answer very short. 11.17. What is the difference between the highest and the second highest Rent(as % of GDP) in Equatorial Guinea?
Offer a very short reply. 1.03. What is the difference between the highest and the second highest Rent(as % of GDP) in Iran?
Offer a terse response. 1.32. What is the difference between the highest and the second highest Rent(as % of GDP) in Pakistan?
Your answer should be very brief. 0.48. What is the difference between the highest and the lowest Rent(as % of GDP) in Middle East & North Africa (all income levels)?
Your answer should be very brief. 20.06. What is the difference between the highest and the lowest Rent(as % of GDP) of Equatorial Guinea?
Make the answer very short. 61.89. What is the difference between the highest and the lowest Rent(as % of GDP) in Iran?
Your answer should be compact. 19.25. What is the difference between the highest and the lowest Rent(as % of GDP) in Pakistan?
Your response must be concise. 0.76. 